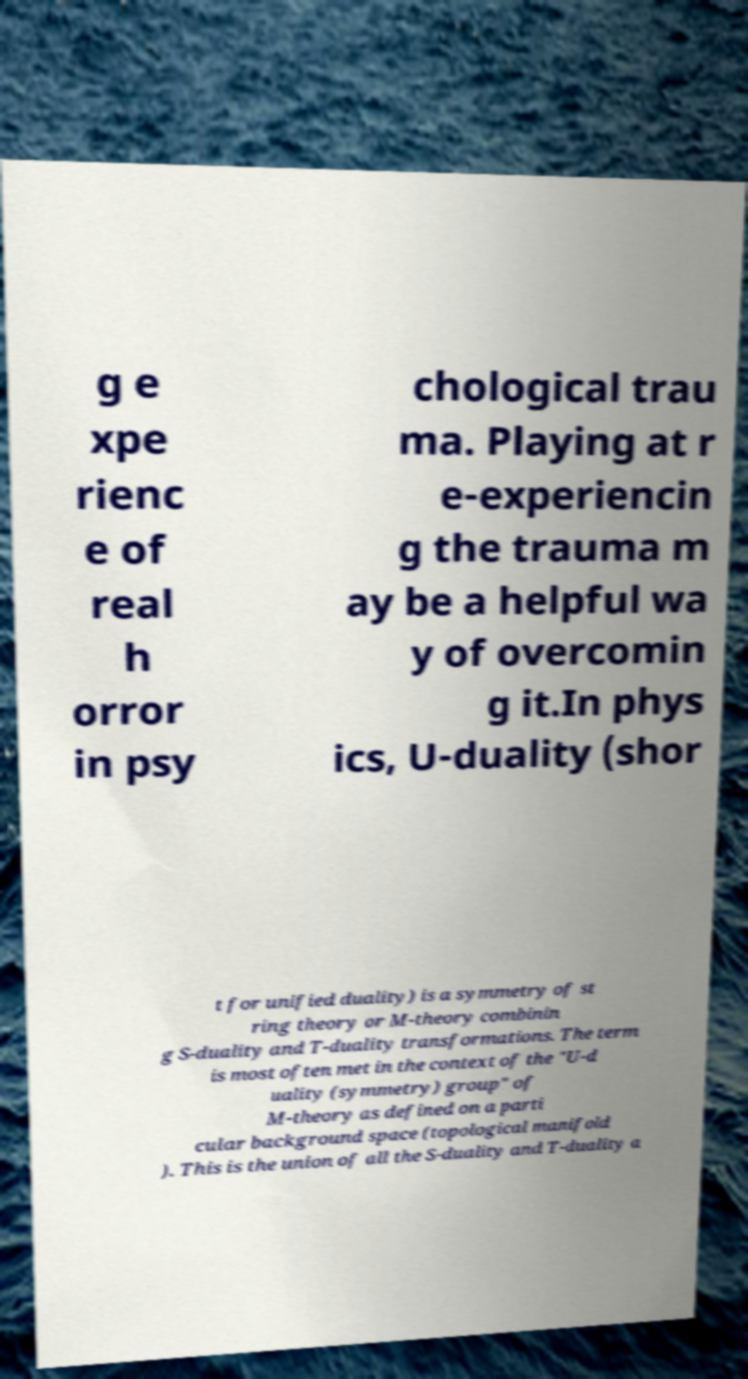Could you extract and type out the text from this image? g e xpe rienc e of real h orror in psy chological trau ma. Playing at r e-experiencin g the trauma m ay be a helpful wa y of overcomin g it.In phys ics, U-duality (shor t for unified duality) is a symmetry of st ring theory or M-theory combinin g S-duality and T-duality transformations. The term is most often met in the context of the "U-d uality (symmetry) group" of M-theory as defined on a parti cular background space (topological manifold ). This is the union of all the S-duality and T-duality a 